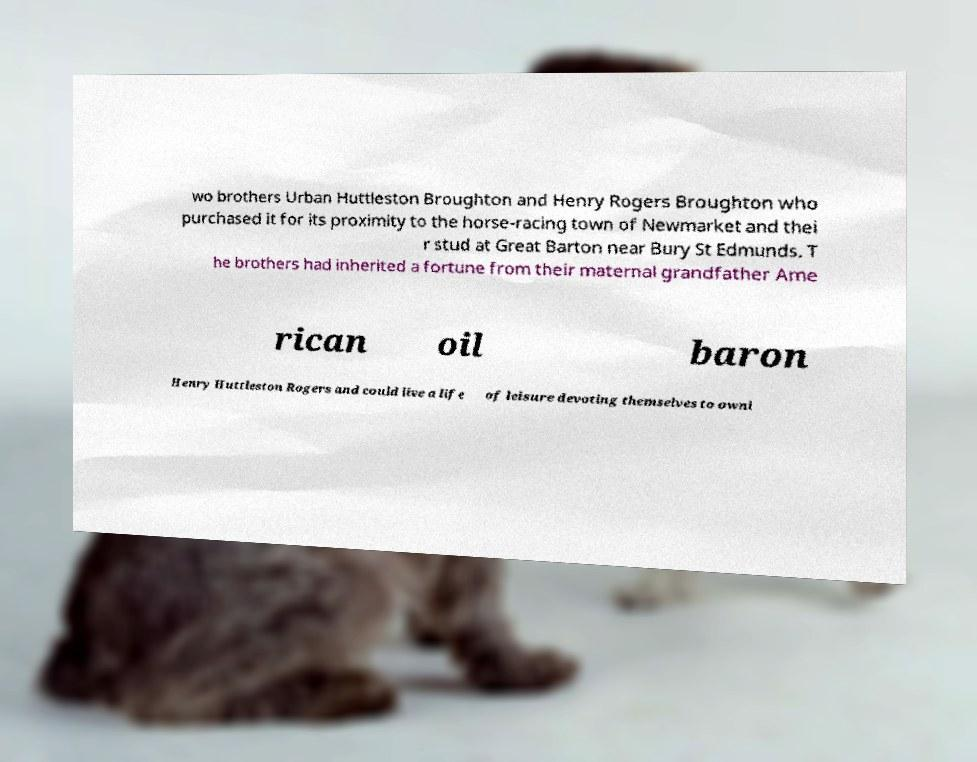Could you assist in decoding the text presented in this image and type it out clearly? wo brothers Urban Huttleston Broughton and Henry Rogers Broughton who purchased it for its proximity to the horse-racing town of Newmarket and thei r stud at Great Barton near Bury St Edmunds. T he brothers had inherited a fortune from their maternal grandfather Ame rican oil baron Henry Huttleston Rogers and could live a life of leisure devoting themselves to owni 